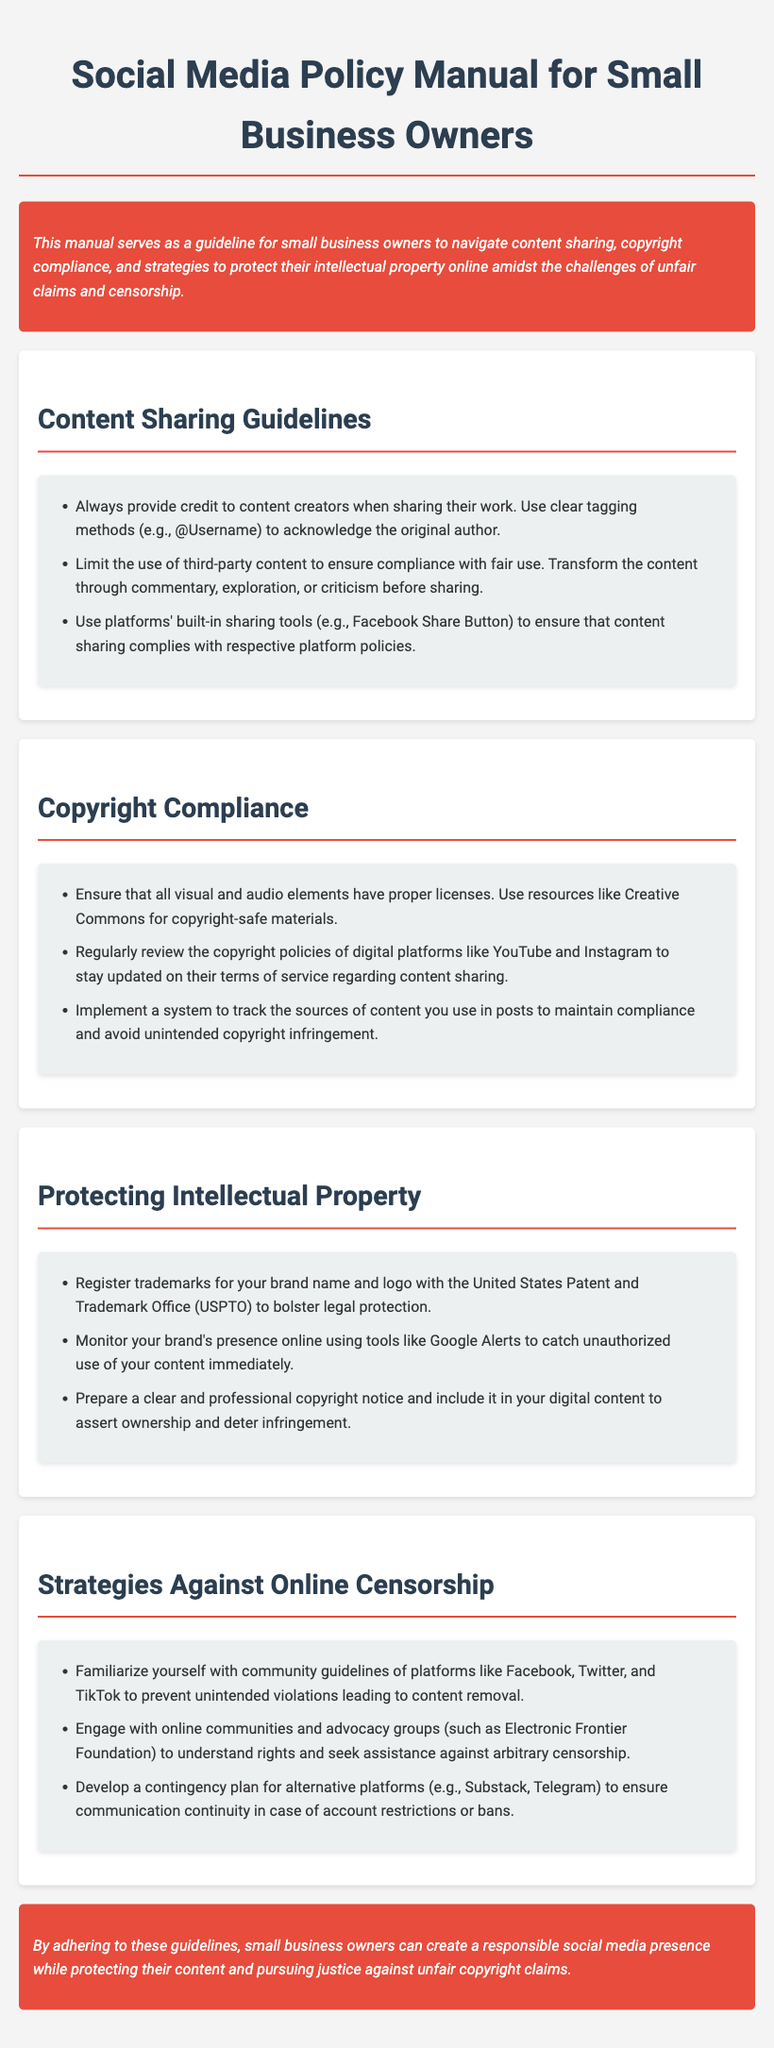What is the title of the manual? The title of the manual is given at the top of the document.
Answer: Social Media Policy Manual for Small Business Owners What should you do when sharing third-party content? The guidelines indicate how to properly handle third-party content before sharing.
Answer: Transform the content through commentary, exploration, or criticism What resource can help ensure copyright compliance for visual elements? The manual suggests using specific resources for copyright-safe materials.
Answer: Creative Commons What is one way to protect your brand's intellectual property? The manual outlines measures to safeguard intellectual property.
Answer: Register trademarks How can you monitor unauthorized use of your content? The document provides a method for tracking brand presence online.
Answer: Google Alerts What platforms should you familiarize yourself with regarding community guidelines? The manual lists platforms that have specific community guidelines to be aware of.
Answer: Facebook, Twitter, and TikTok What type of notice should be included in digital content? The guidelines emphasize the importance of a legal framework for asserting ownership.
Answer: Copyright notice What is the purpose of engaging with advocacy groups? The manual suggests a reason for connecting with online communities.
Answer: Seek assistance against arbitrary censorship 